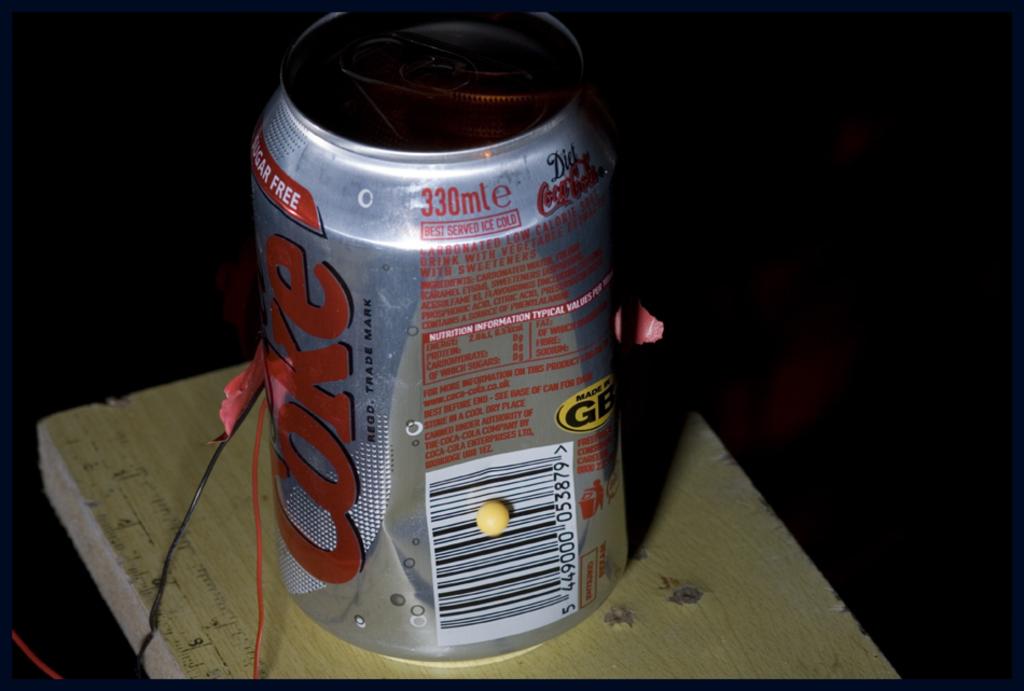How many ml in this can?
Provide a succinct answer. 330. 